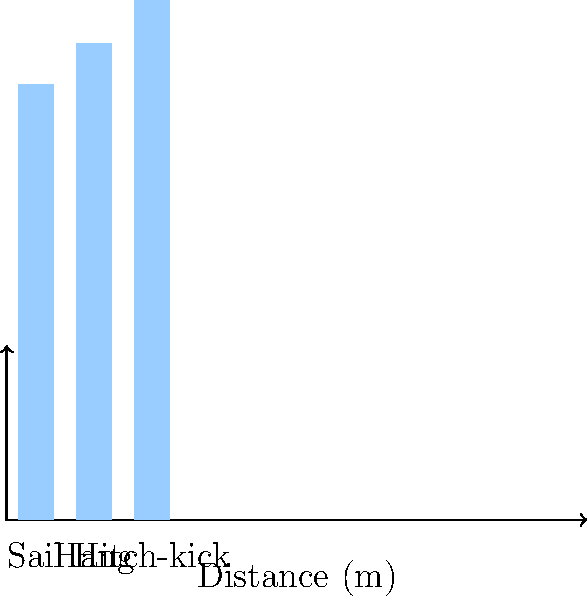Based on the graph showing the average distances achieved by different long jump techniques, which technique would you recommend to a novice jumper aiming to quickly improve their performance? To answer this question, let's analyze the data presented in the graph:

1. The graph shows three long jump techniques: Sail, Hang, and Hitch-kick.
2. The average distances achieved for each technique are:
   - Sail: approximately 7.5 meters
   - Hang: approximately 8.2 meters
   - Hitch-kick: approximately 8.95 meters

3. For a novice jumper looking to quickly improve performance, we should consider:
   a) Ease of learning: Generally, simpler techniques are easier to master initially.
   b) Potential for improvement: Techniques that offer a good balance of initial performance and room for growth are ideal.

4. The Sail technique, while showing the shortest distance, is typically the easiest to learn and execute. It's often taught to beginners as a foundation.

5. The Hang technique offers a middle ground. It shows a significant improvement over the Sail (about 0.7 meters) and is relatively easier to learn compared to the Hitch-kick.

6. The Hitch-kick technique, while offering the best performance, is the most complex and typically requires more time and practice to master effectively.

Given these considerations, the Hang technique would be the most suitable recommendation for a novice jumper aiming to quickly improve their performance. It offers a good balance between ease of learning and performance improvement, allowing the jumper to see significant gains over the basic Sail technique without the complexity of the Hitch-kick.
Answer: Hang technique 